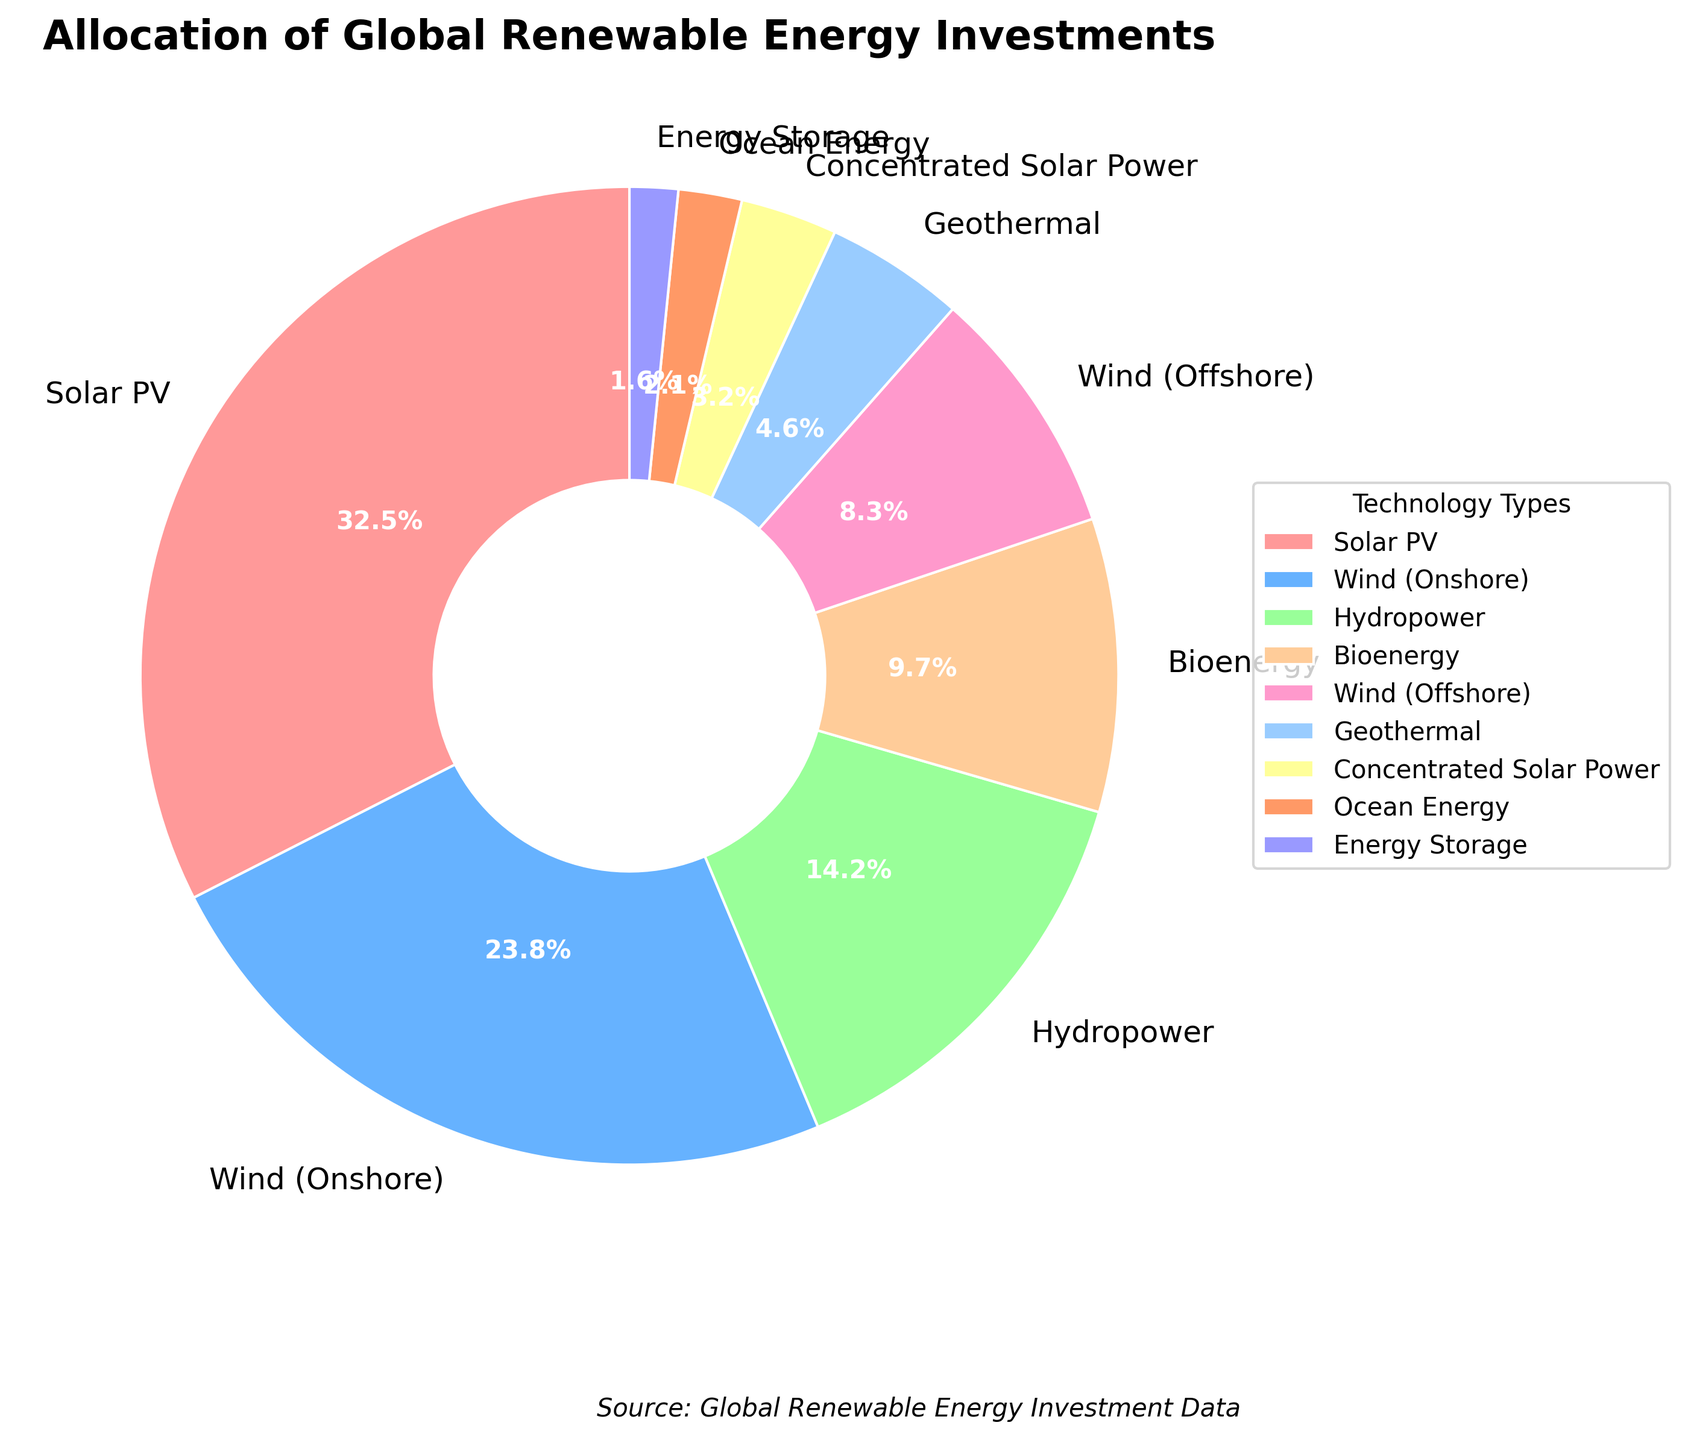What percentage of the investment goes to solar technologies, including both Solar PV and Concentrated Solar Power? Add Solar PV's percentage (32.5%) to Concentrated Solar Power's percentage (3.2%). 32.5 + 3.2 = 35.7
Answer: 35.7% Which technology type receives less investment, Bioenergy or Geothermal? Compare the percentage values of Bioenergy (9.7%) and Geothermal (4.6%). 4.6 is less than 9.7
Answer: Geothermal What is the combined investment percentage for Wind technologies (both onshore and offshore)? Add Wind (Onshore)'s percentage (23.8%) to Wind (Offshore)'s percentage (8.3%). 23.8 + 8.3 = 32.1
Answer: 32.1% Which technology type is invested in the least? Find the smallest percentage among all values. Ocean Energy at 2.1% is the lowest
Answer: Ocean Energy Are the investments in Wind (Onshore) and Solar PV almost equal? Compare the percentages of Wind (Onshore) (23.8%) and Solar PV (32.5%). 23.8 is not almost equal to 32.5
Answer: No Does Hydropower receive more investment than Bioenergy and Geothermal combined? Add the percentages of Bioenergy (9.7%) and Geothermal (4.6%). 9.7 + 4.6 = 14.3. Compare Hydropower (14.2%) and the combined total (14.3%). 14.2 is less than 14.3
Answer: No What are the colors of the wedges representing the highest and lowest investments? The wedges for Solar PV (highest, 32.5%) and Ocean Energy (lowest, 2.1%) are colored in red and blue, respectively
Answer: Red and blue 